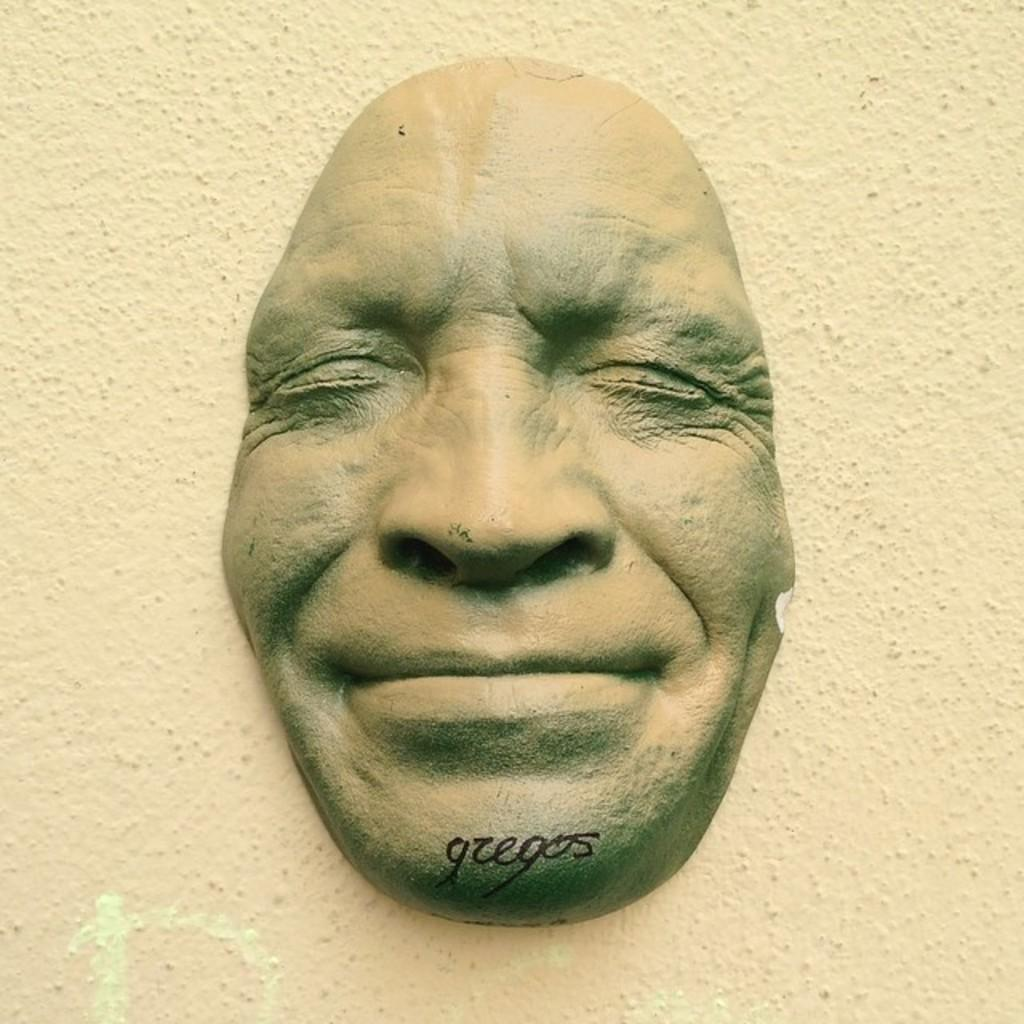What is the main subject of the image? The main subject of the image is a mask of a person's face. How many fingers can be seen on the mask in the image? There are no fingers present on the mask in the image, as it is a mask of a person's face and not a representation of a person's hand. 